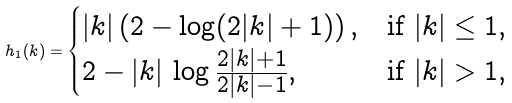<formula> <loc_0><loc_0><loc_500><loc_500>h _ { 1 } ( k ) = \begin{cases} | k | \left ( 2 - \log ( 2 | k | + 1 ) \right ) , & \text {if $| k | \leq 1$} , \\ 2 - | k | \, \log \frac { 2 | k | + 1 } { 2 | k | - 1 } , & \text {if $| k | > 1$} , \end{cases}</formula> 